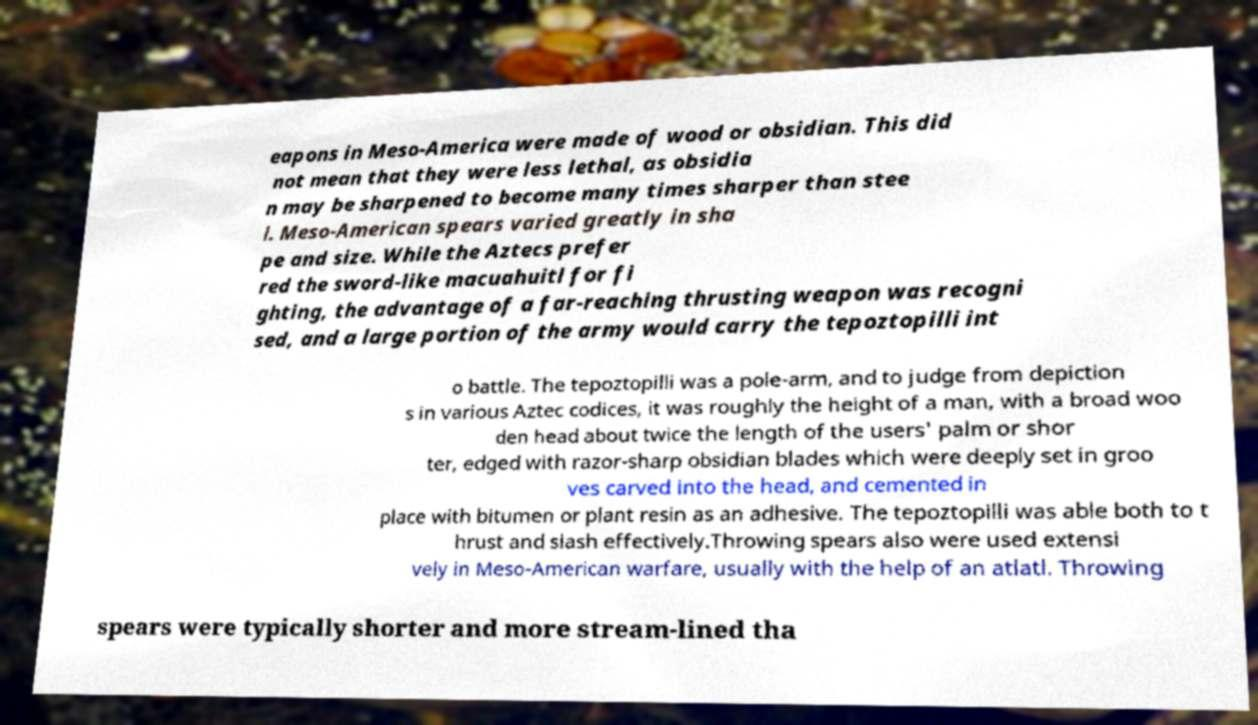Could you extract and type out the text from this image? eapons in Meso-America were made of wood or obsidian. This did not mean that they were less lethal, as obsidia n may be sharpened to become many times sharper than stee l. Meso-American spears varied greatly in sha pe and size. While the Aztecs prefer red the sword-like macuahuitl for fi ghting, the advantage of a far-reaching thrusting weapon was recogni sed, and a large portion of the army would carry the tepoztopilli int o battle. The tepoztopilli was a pole-arm, and to judge from depiction s in various Aztec codices, it was roughly the height of a man, with a broad woo den head about twice the length of the users' palm or shor ter, edged with razor-sharp obsidian blades which were deeply set in groo ves carved into the head, and cemented in place with bitumen or plant resin as an adhesive. The tepoztopilli was able both to t hrust and slash effectively.Throwing spears also were used extensi vely in Meso-American warfare, usually with the help of an atlatl. Throwing spears were typically shorter and more stream-lined tha 